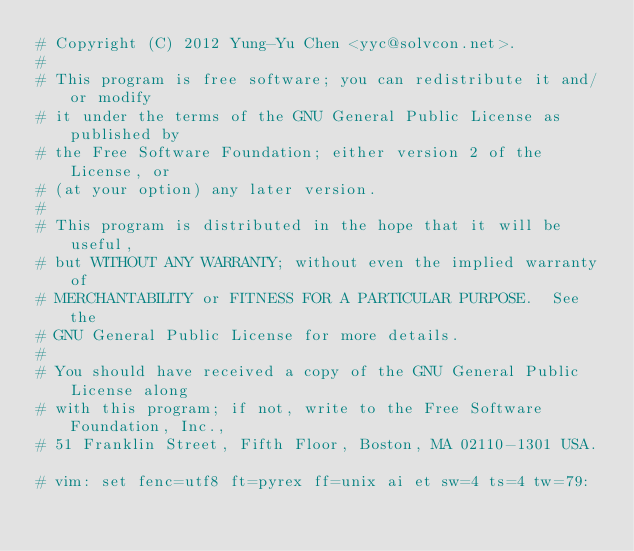<code> <loc_0><loc_0><loc_500><loc_500><_Cython_># Copyright (C) 2012 Yung-Yu Chen <yyc@solvcon.net>.
#
# This program is free software; you can redistribute it and/or modify
# it under the terms of the GNU General Public License as published by
# the Free Software Foundation; either version 2 of the License, or
# (at your option) any later version.
#
# This program is distributed in the hope that it will be useful,
# but WITHOUT ANY WARRANTY; without even the implied warranty of
# MERCHANTABILITY or FITNESS FOR A PARTICULAR PURPOSE.  See the
# GNU General Public License for more details.
# 
# You should have received a copy of the GNU General Public License along
# with this program; if not, write to the Free Software Foundation, Inc.,
# 51 Franklin Street, Fifth Floor, Boston, MA 02110-1301 USA.

# vim: set fenc=utf8 ft=pyrex ff=unix ai et sw=4 ts=4 tw=79:
</code> 